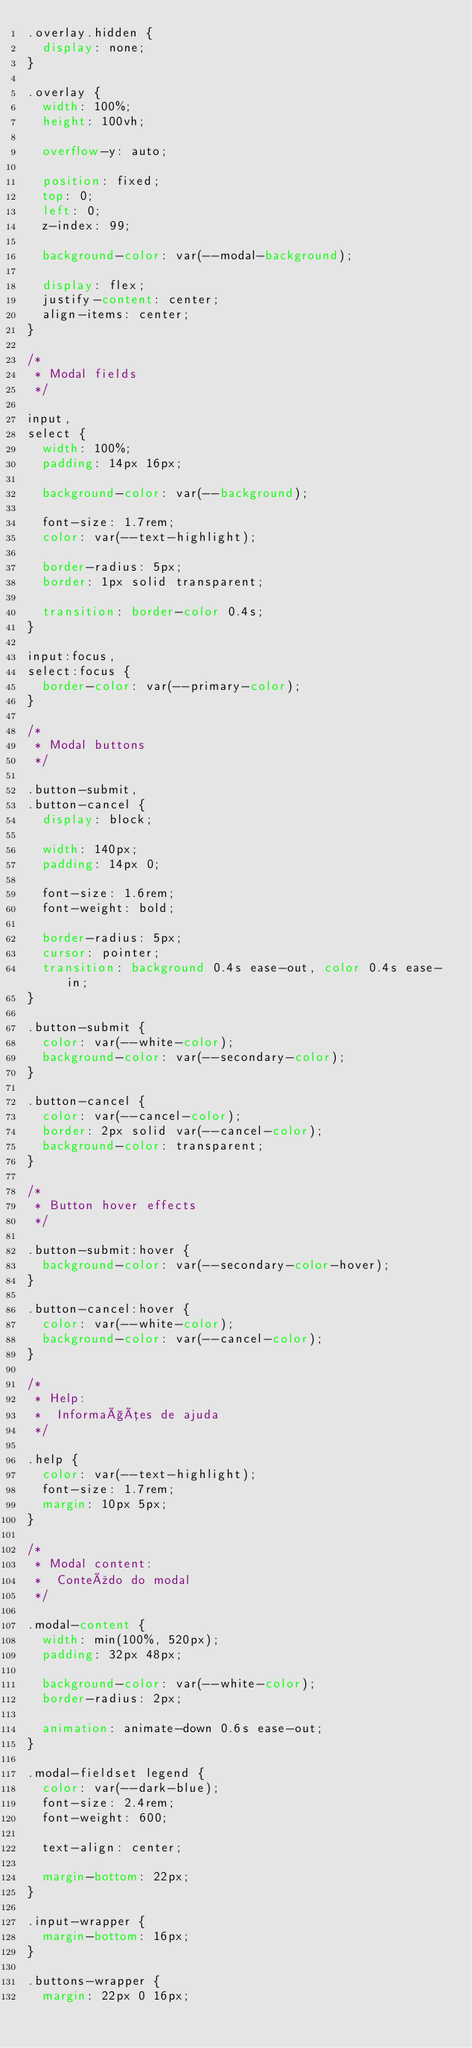<code> <loc_0><loc_0><loc_500><loc_500><_CSS_>.overlay.hidden {
  display: none;
}

.overlay {
  width: 100%;
  height: 100vh;

  overflow-y: auto;

  position: fixed;
  top: 0;
  left: 0;
  z-index: 99;

  background-color: var(--modal-background);

  display: flex;
  justify-content: center;
  align-items: center;
}

/* 
 * Modal fields
 */

input,
select {
  width: 100%;
  padding: 14px 16px;

  background-color: var(--background);

  font-size: 1.7rem;
  color: var(--text-highlight);

  border-radius: 5px;
  border: 1px solid transparent;

  transition: border-color 0.4s;
}

input:focus,
select:focus {
  border-color: var(--primary-color);
}

/* 
 * Modal buttons
 */

.button-submit,
.button-cancel {
  display: block;

  width: 140px;
  padding: 14px 0;

  font-size: 1.6rem;
  font-weight: bold;

  border-radius: 5px;
  cursor: pointer;
  transition: background 0.4s ease-out, color 0.4s ease-in;
}

.button-submit {
  color: var(--white-color);
  background-color: var(--secondary-color);
}

.button-cancel {
  color: var(--cancel-color);
  border: 2px solid var(--cancel-color);
  background-color: transparent;
}

/* 
 * Button hover effects
 */

.button-submit:hover {
  background-color: var(--secondary-color-hover);
}

.button-cancel:hover {
  color: var(--white-color);
  background-color: var(--cancel-color);
}

/* 
 * Help:
 *  Informações de ajuda
 */

.help {
  color: var(--text-highlight);
  font-size: 1.7rem;
  margin: 10px 5px;
}

/* 
 * Modal content:
 *  Conteúdo do modal
 */

.modal-content {
  width: min(100%, 520px);
  padding: 32px 48px;

  background-color: var(--white-color);
  border-radius: 2px;

  animation: animate-down 0.6s ease-out;
}

.modal-fieldset legend {
  color: var(--dark-blue);
  font-size: 2.4rem;
  font-weight: 600;

  text-align: center;

  margin-bottom: 22px;
}

.input-wrapper {
  margin-bottom: 16px;
}

.buttons-wrapper {
  margin: 22px 0 16px;
</code> 